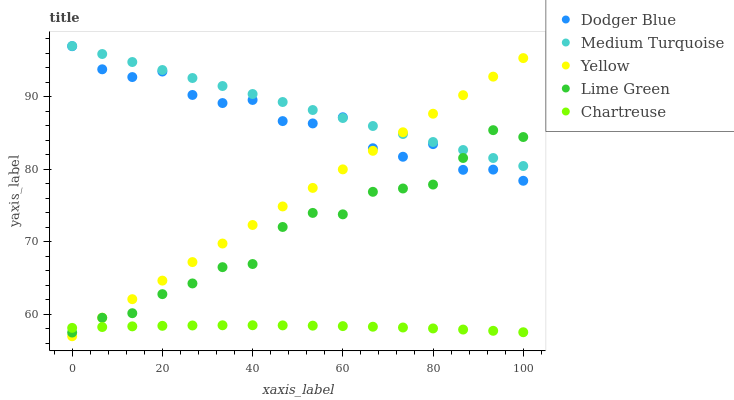Does Chartreuse have the minimum area under the curve?
Answer yes or no. Yes. Does Medium Turquoise have the maximum area under the curve?
Answer yes or no. Yes. Does Dodger Blue have the minimum area under the curve?
Answer yes or no. No. Does Dodger Blue have the maximum area under the curve?
Answer yes or no. No. Is Medium Turquoise the smoothest?
Answer yes or no. Yes. Is Dodger Blue the roughest?
Answer yes or no. Yes. Is Chartreuse the smoothest?
Answer yes or no. No. Is Chartreuse the roughest?
Answer yes or no. No. Does Yellow have the lowest value?
Answer yes or no. Yes. Does Chartreuse have the lowest value?
Answer yes or no. No. Does Medium Turquoise have the highest value?
Answer yes or no. Yes. Does Dodger Blue have the highest value?
Answer yes or no. No. Is Chartreuse less than Dodger Blue?
Answer yes or no. Yes. Is Medium Turquoise greater than Chartreuse?
Answer yes or no. Yes. Does Lime Green intersect Yellow?
Answer yes or no. Yes. Is Lime Green less than Yellow?
Answer yes or no. No. Is Lime Green greater than Yellow?
Answer yes or no. No. Does Chartreuse intersect Dodger Blue?
Answer yes or no. No. 